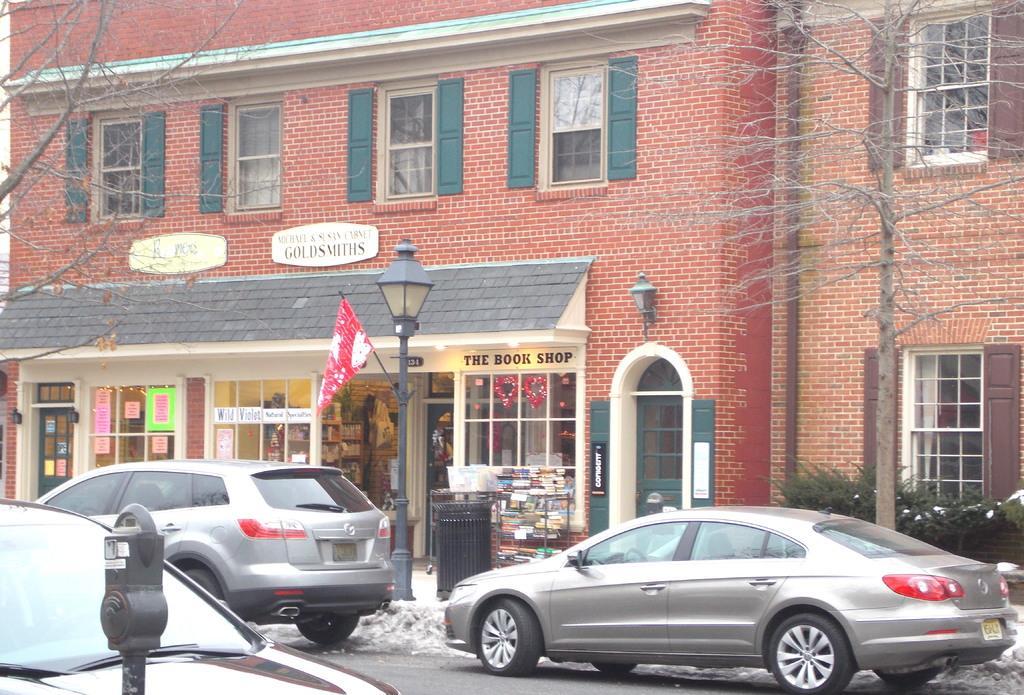In one or two sentences, can you explain what this image depicts? In this image I can see the group vehicles on the road. To the left I can see the pole. In the background I can see the pole, flag, trees and the dustbin. I can also see the windows and boards to the building. 